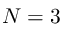Convert formula to latex. <formula><loc_0><loc_0><loc_500><loc_500>N = 3</formula> 